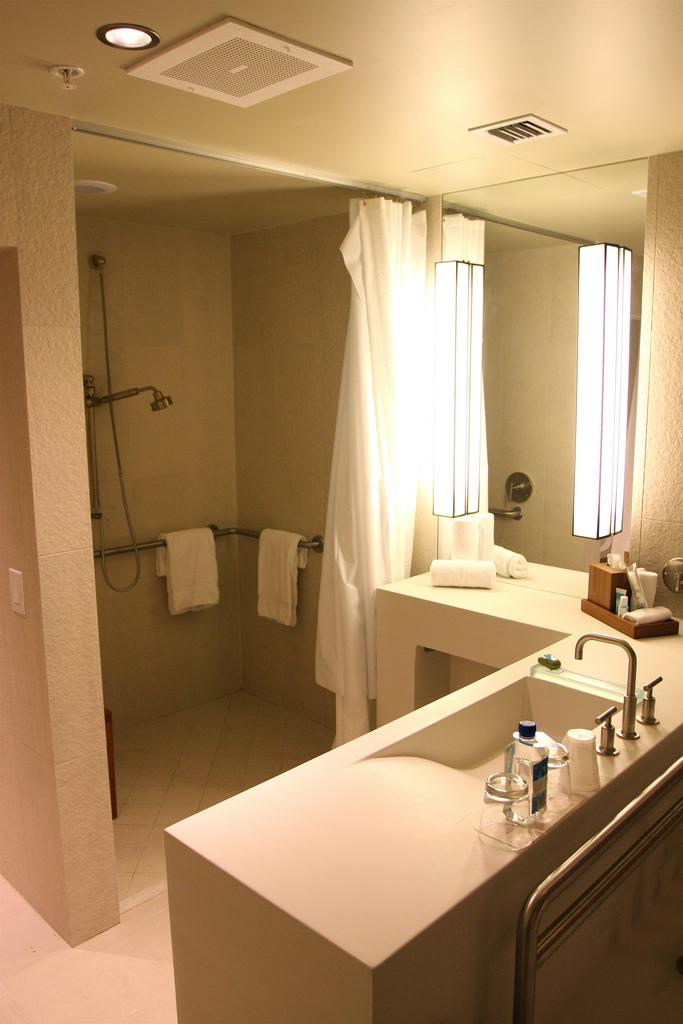What object is located near the top of the image and what is its size? The rectangular speaker in the ceiling is near the top of the image, with width 235 and height 235. Expressly enumerate the objects hanging in the shower and their dimensions. Two towels are hanging in the shower with width 159 and height 159, a white towel with width 104 and height 104, and another white towel with width 61 and height 61. Count the number of white towels in the bathroom, and mention one of their sizes. There are 7 white towels in the bathroom, one of them has width 26 and height 26. How many pink decorative candles can you find placed around the bathroom? There's a small, round window above the rectangular speaker in the ceiling - note its position and size. Identify which objects in the image are interacting with each other. The two towels hanging in the shower are interacting with the showerhead as they are placed in close proximity. Which object in the bathroom is closest to the floor tiles? Clear glass in the bathroom - X:485, Y:772, Width:42, Height:42 List the features of the white sink in the bathroom, including its position and dimensions. Position: X:444, Y:653, Dimensions: Width:105, Height:105, Color: White, Material: Ceramic Identify any abnormal occurrences or elements in the image. No abnormalities or anomalies are detected in the image. Can you locate the purple shampoo bottle on the corner of the bathtub? Find the green potted plant next to the sink in the bathroom. Evaluate the quality of the image in terms of clarity and sharpness. The image appears to have high quality with sharp details and clear visibility. Describe the position and size of the rolled up towel that is standing up. X:446, Y:507, Width:31, Height:31 Determine the location and dimensions of the white light switch in the bathroom. X:1, Y:556, Width:35, Height:35 Describe the location of the white towel hanging closest to the silver showerhead. X:140, Y:521, Width:104, Height:104 Analyze the overall sentiment evoked by the image. The image evokes a sense of cleanliness and serenity. Detect any text present in the image. There is no visible text in the image. What is the size and position of the rectangular speaker in the ceiling? X:119, Y:12, Width:235, Height:235 Identify the sentiment conveyed by this bathroom image. Clean, organized, and calming Identify any textual content observable in the image. No text is present or visible in the image. How would you assess the image quality? The image quality is high and clear. Determine any anomalies in the image. There are no apparent anomalies in the image. Describe the location and size of the largest floor tile depicted in the image. X:178, Y:717, Width:34, Height:34 How many white towels are shown in the bathroom image with their positions and sizes? 7 towels - X:156 Y:524 Width:72 Height:72; X:247 Y:524 Width:53 Height:53; X:420 Y:549 Width:64 Height:64; X:486 Y:539 Width:38 Height:38; X:449 Y:503 Width:26 Height:26; X:469 Y:502 Width:23 Height:23; X:619 Y:596 Width:47 Height:47 Identify the attributes of the brown wood tissue box in the image. X:584, Y:557, Width:57, Height:57, Material: Wood, Color: Brown Examine the interaction between the rolled up towels on the counter and the brown wood tissue box. The rolled up towels and the tissue box are placed closely on the counter, suggesting they are related objects for organization. 